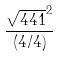Convert formula to latex. <formula><loc_0><loc_0><loc_500><loc_500>\frac { \sqrt { 4 4 1 } ^ { 2 } } { ( 4 / 4 ) }</formula> 